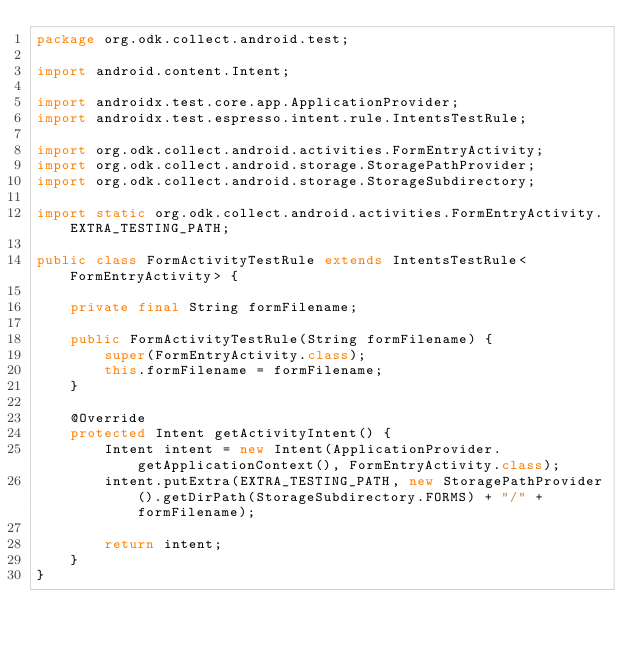<code> <loc_0><loc_0><loc_500><loc_500><_Java_>package org.odk.collect.android.test;

import android.content.Intent;

import androidx.test.core.app.ApplicationProvider;
import androidx.test.espresso.intent.rule.IntentsTestRule;

import org.odk.collect.android.activities.FormEntryActivity;
import org.odk.collect.android.storage.StoragePathProvider;
import org.odk.collect.android.storage.StorageSubdirectory;

import static org.odk.collect.android.activities.FormEntryActivity.EXTRA_TESTING_PATH;

public class FormActivityTestRule extends IntentsTestRule<FormEntryActivity> {

    private final String formFilename;

    public FormActivityTestRule(String formFilename) {
        super(FormEntryActivity.class);
        this.formFilename = formFilename;
    }

    @Override
    protected Intent getActivityIntent() {
        Intent intent = new Intent(ApplicationProvider.getApplicationContext(), FormEntryActivity.class);
        intent.putExtra(EXTRA_TESTING_PATH, new StoragePathProvider().getDirPath(StorageSubdirectory.FORMS) + "/" + formFilename);

        return intent;
    }
}
</code> 